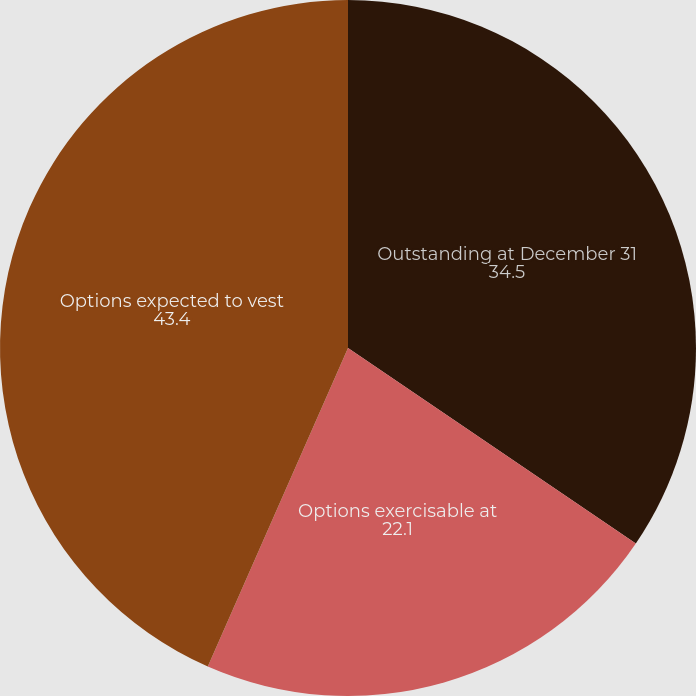Convert chart to OTSL. <chart><loc_0><loc_0><loc_500><loc_500><pie_chart><fcel>Outstanding at December 31<fcel>Options exercisable at<fcel>Options expected to vest<nl><fcel>34.5%<fcel>22.1%<fcel>43.4%<nl></chart> 